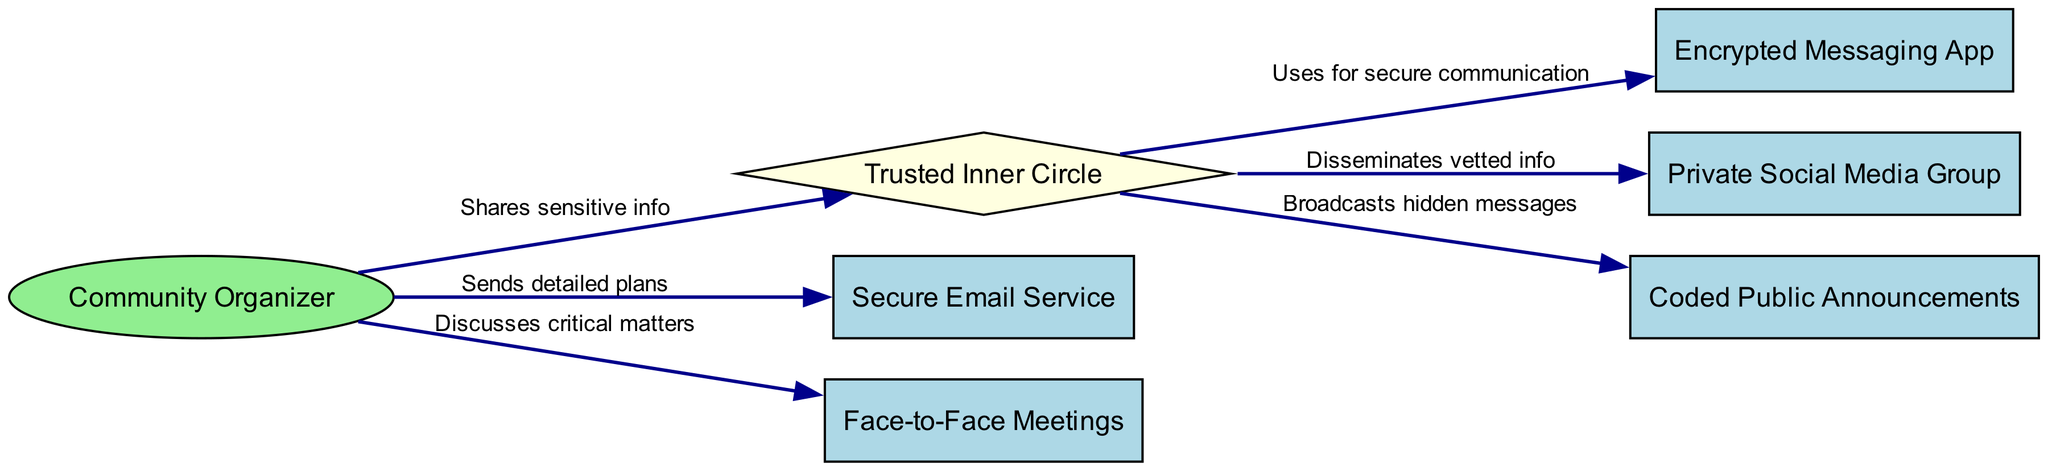What is the total number of nodes in the diagram? Counting the unique entities present, we identify the nodes: Community Organizer, Trusted Inner Circle, Encrypted Messaging App, Private Social Media Group, Secure Email Service, Face-to-Face Meetings, and Coded Public Announcements, totaling 7 nodes.
Answer: 7 Which node is connected directly to the Trusted Inner Circle? The edges show that the Trusted Inner Circle connects to three nodes: Encrypted Messaging App, Private Social Media Group, and Coded Public Announcements.
Answer: Encrypted Messaging App, Private Social Media Group, Coded Public Announcements What action does the Community Organizer take toward the Secure Email Service? The edge from Community Organizer to Secure Email Service is labeled "Sends detailed plans," indicating a direct action of sending information.
Answer: Sends detailed plans How many edges originate from the Community Organizer? The edges show that the Community Organizer has two outgoing connections: one to Secure Email Service and another to Face-to-Face Meetings, totaling 2 edges.
Answer: 2 What type of information is disseminated through the Private Social Media Group? The connection from Trusted Inner Circle to Private Social Media Group is labeled "Disseminates vetted info," which indicates the nature of the information shared.
Answer: Vetted info Which communication method is used for secure communication with the Trusted Inner Circle? The directed edge from Trusted Inner Circle to Encrypted Messaging App specifies that this method is employed for secure communication, denoting its importance.
Answer: Encrypted Messaging App What type of announcements does the Trusted Inner Circle use for broadcasting hidden messages? The labeled edge connecting Trusted Inner Circle to Coded Public Announcements indicates that this method is specifically used for broadcasting messages that are not overtly clear.
Answer: Coded Public Announcements What relationship exists between the Community Organizer and Face-to-Face Meetings? There is a directed edge from Community Organizer to Face-to-Face Meetings labeled "Discusses critical matters," revealing the purpose of these meetings.
Answer: Discusses critical matters 